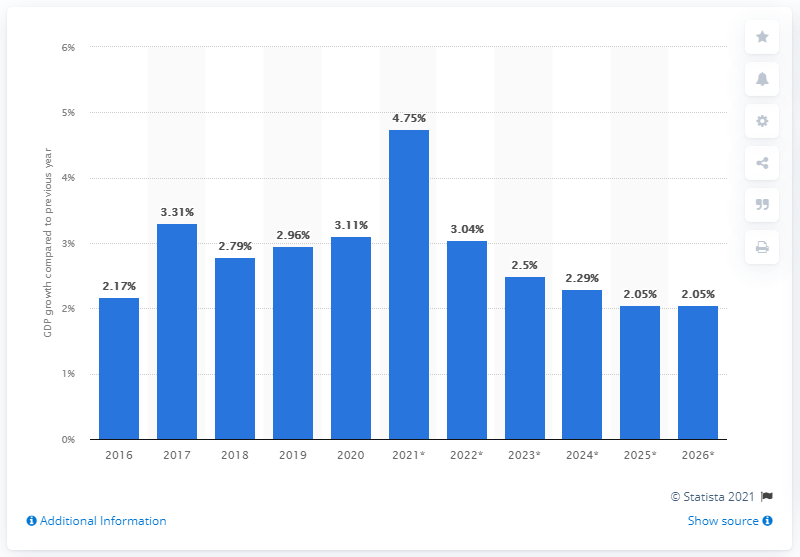Give some essential details in this illustration. In 2020, the real gross domestic product of Taiwan grew by 3.11 percent. 